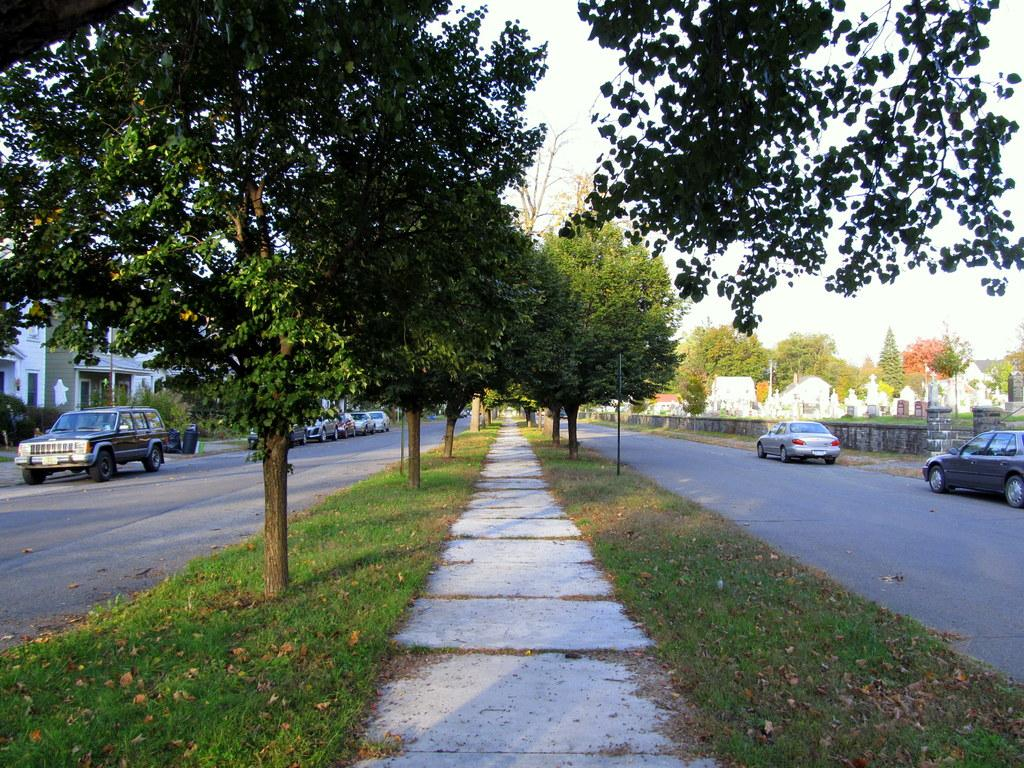What can be seen on the road in the image? There are vehicles on the road in the image. What type of surface is visible next to the road? There is a pathway visible in the image. What type of vegetation is present in the image? Grass is present in the image. Where can trees be found in the image? There is a group of trees in the image. What is the container used for in the image? The purpose of the container is not specified in the image. What type of structures are visible in the image? There are buildings in the image. What type of barrier is present in the image? A fence is present in the image. What are the poles used for in the image? The purpose of the poles is not specified in the image. What is the weather like in the image? The sky is visible in the image, and it appears cloudy. Can you see the ocean in the image? No, the ocean is not present in the image. What type of spark can be seen coming from the trees? There is no spark visible in the image. What type of silk is draped over the buildings? There is no silk present in the image. 